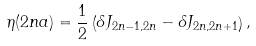Convert formula to latex. <formula><loc_0><loc_0><loc_500><loc_500>\eta ( 2 n a ) = \frac { 1 } { 2 } \left ( \delta J _ { 2 n - 1 , 2 n } - \delta J _ { 2 n , 2 n + 1 } \right ) ,</formula> 